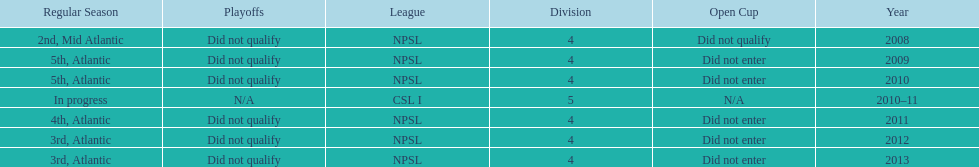How many third place finishes has npsl achieved? 2. 